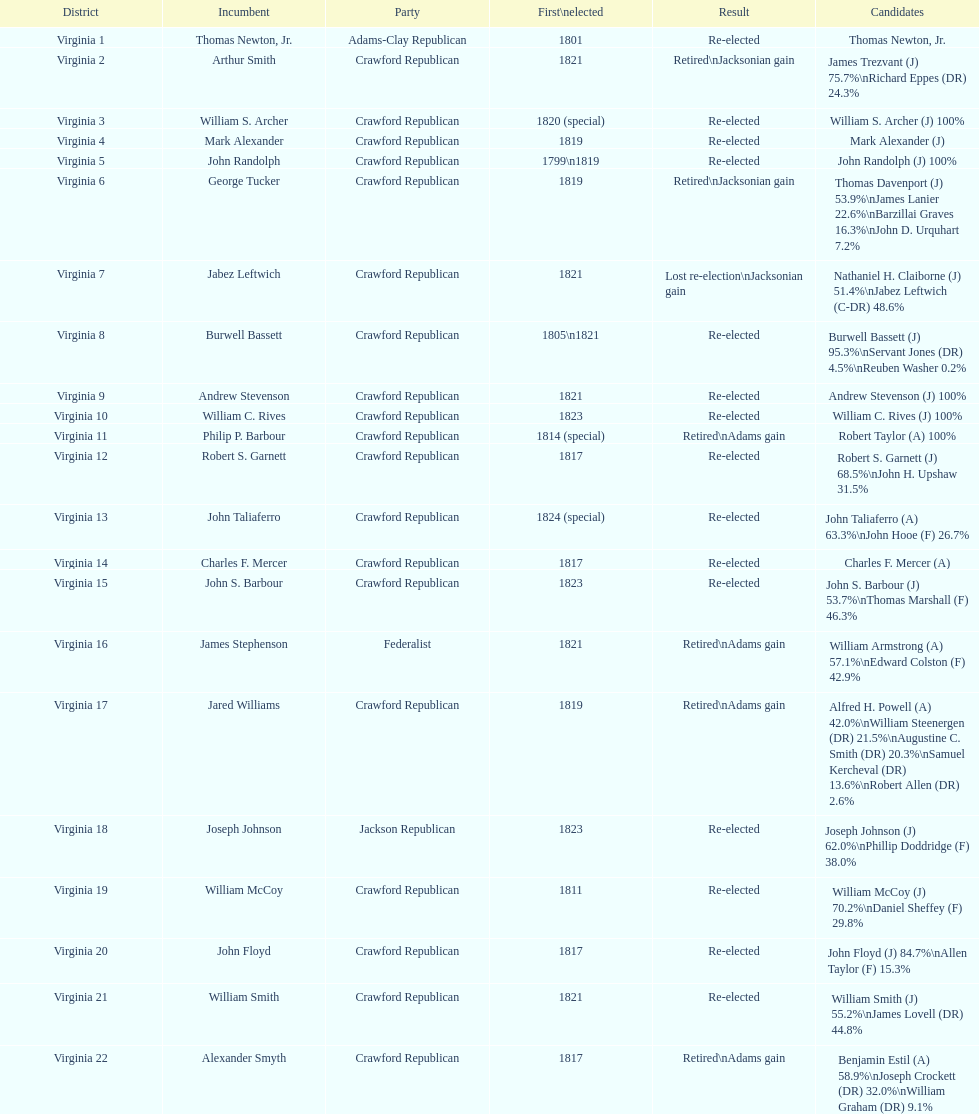What is the count of incumbents who stepped down or failed to win re-election? 7. 